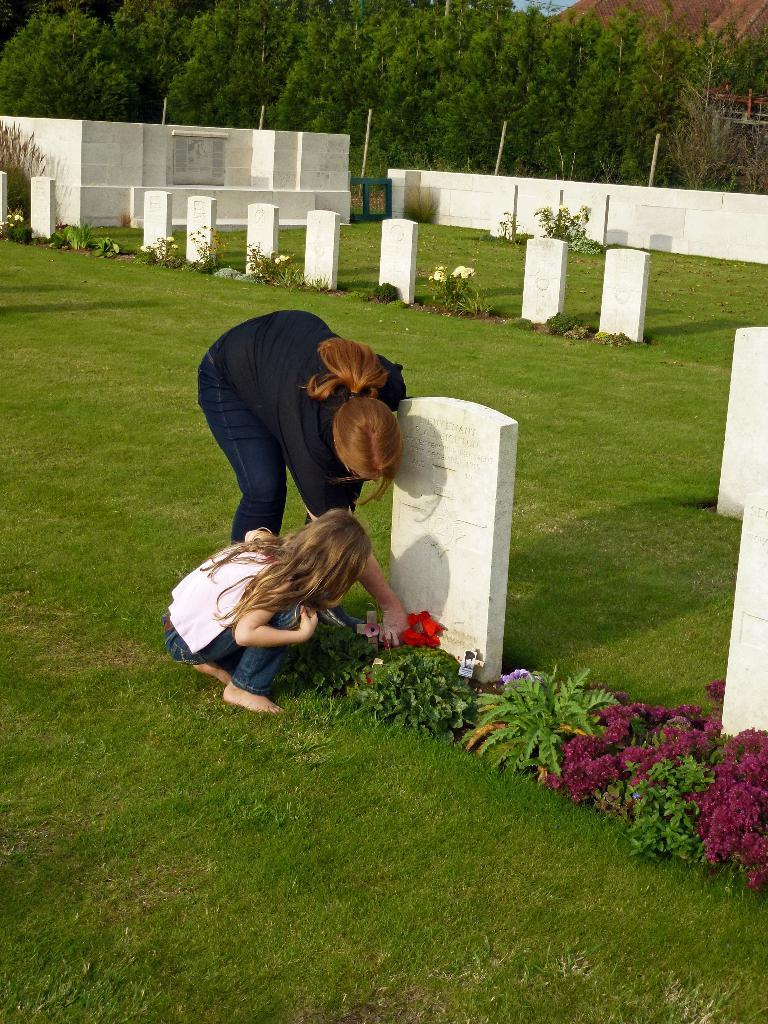What type of ground is visible in the image? There is grass ground in the image. What can be found in the grass ground? There are tombstones in the image. What other natural elements are present in the image? There are plants and flowers in the image. Can you describe the lighting in the image? There are shadows in the image, indicating that there is a light source. How many people are in the image? There are two people in the image. What can be seen in the background of the image? There are trees in the background of the image. What is the weight of the kitten playing with the aftermath in the image? There is no kitten or aftermath present in the image. 